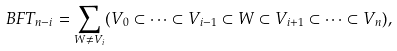Convert formula to latex. <formula><loc_0><loc_0><loc_500><loc_500>\ B F T _ { n - i } = \sum _ { W \ne V _ { i } } ( V _ { 0 } \subset \cdots \subset V _ { i - 1 } \subset W \subset V _ { i + 1 } \subset \cdots \subset V _ { n } ) ,</formula> 